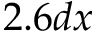Convert formula to latex. <formula><loc_0><loc_0><loc_500><loc_500>2 . 6 d x</formula> 